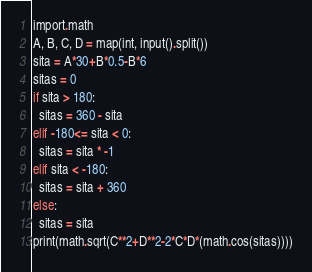Convert code to text. <code><loc_0><loc_0><loc_500><loc_500><_Python_>import.math
A, B, C, D = map(int, input().split())
sita = A*30+B*0.5-B*6
sitas = 0
if sita > 180:
  sitas = 360 - sita
elif -180<= sita < 0:
  sitas = sita * -1
elif sita < -180:
  sitas = sita + 360
else:
  sitas = sita
print(math.sqrt(C**2+D**2-2*C*D*(math.cos(sitas))))</code> 